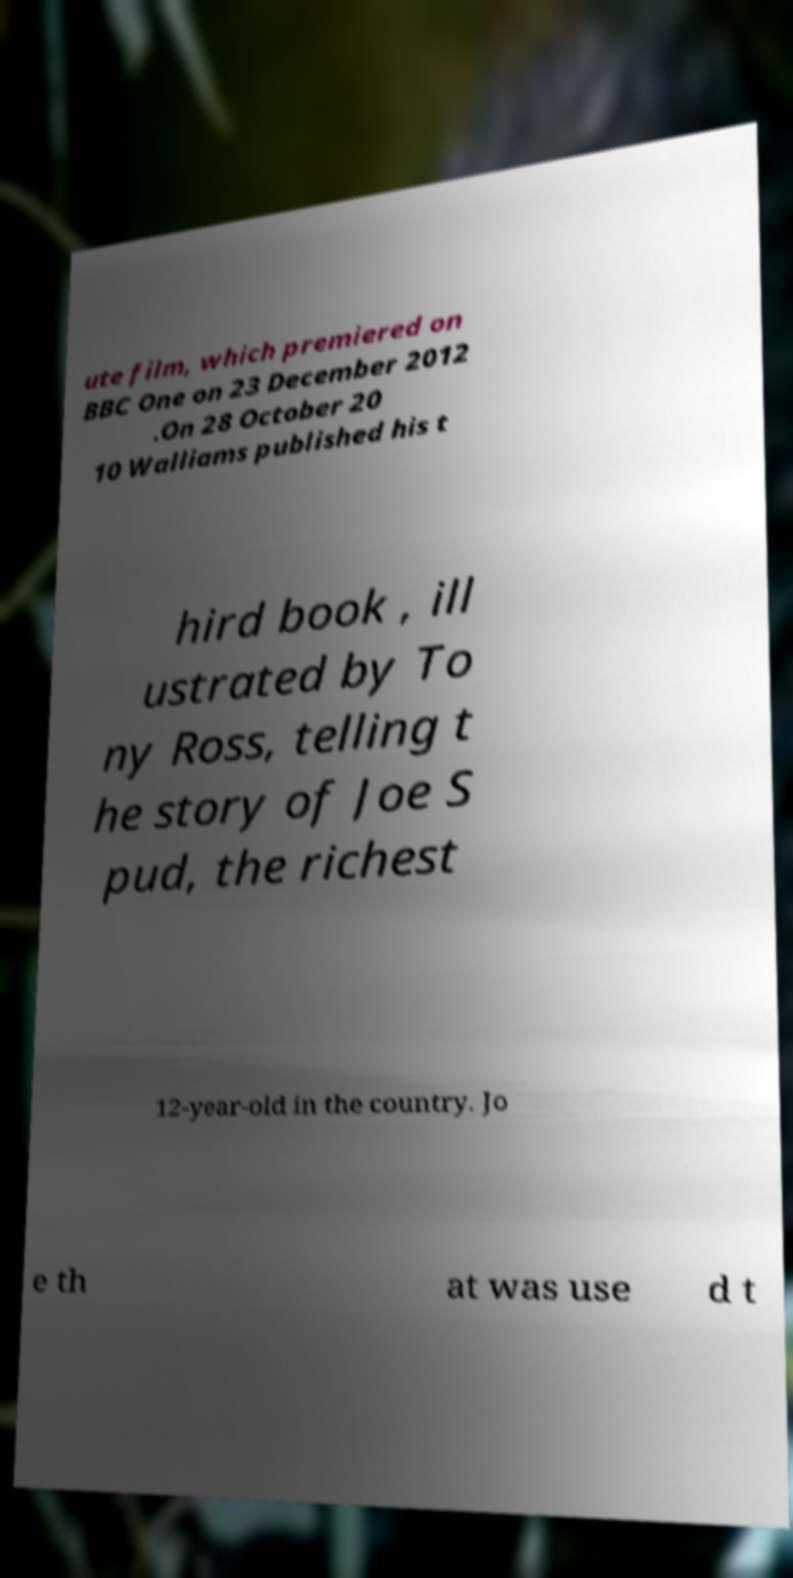Can you accurately transcribe the text from the provided image for me? ute film, which premiered on BBC One on 23 December 2012 .On 28 October 20 10 Walliams published his t hird book , ill ustrated by To ny Ross, telling t he story of Joe S pud, the richest 12-year-old in the country. Jo e th at was use d t 